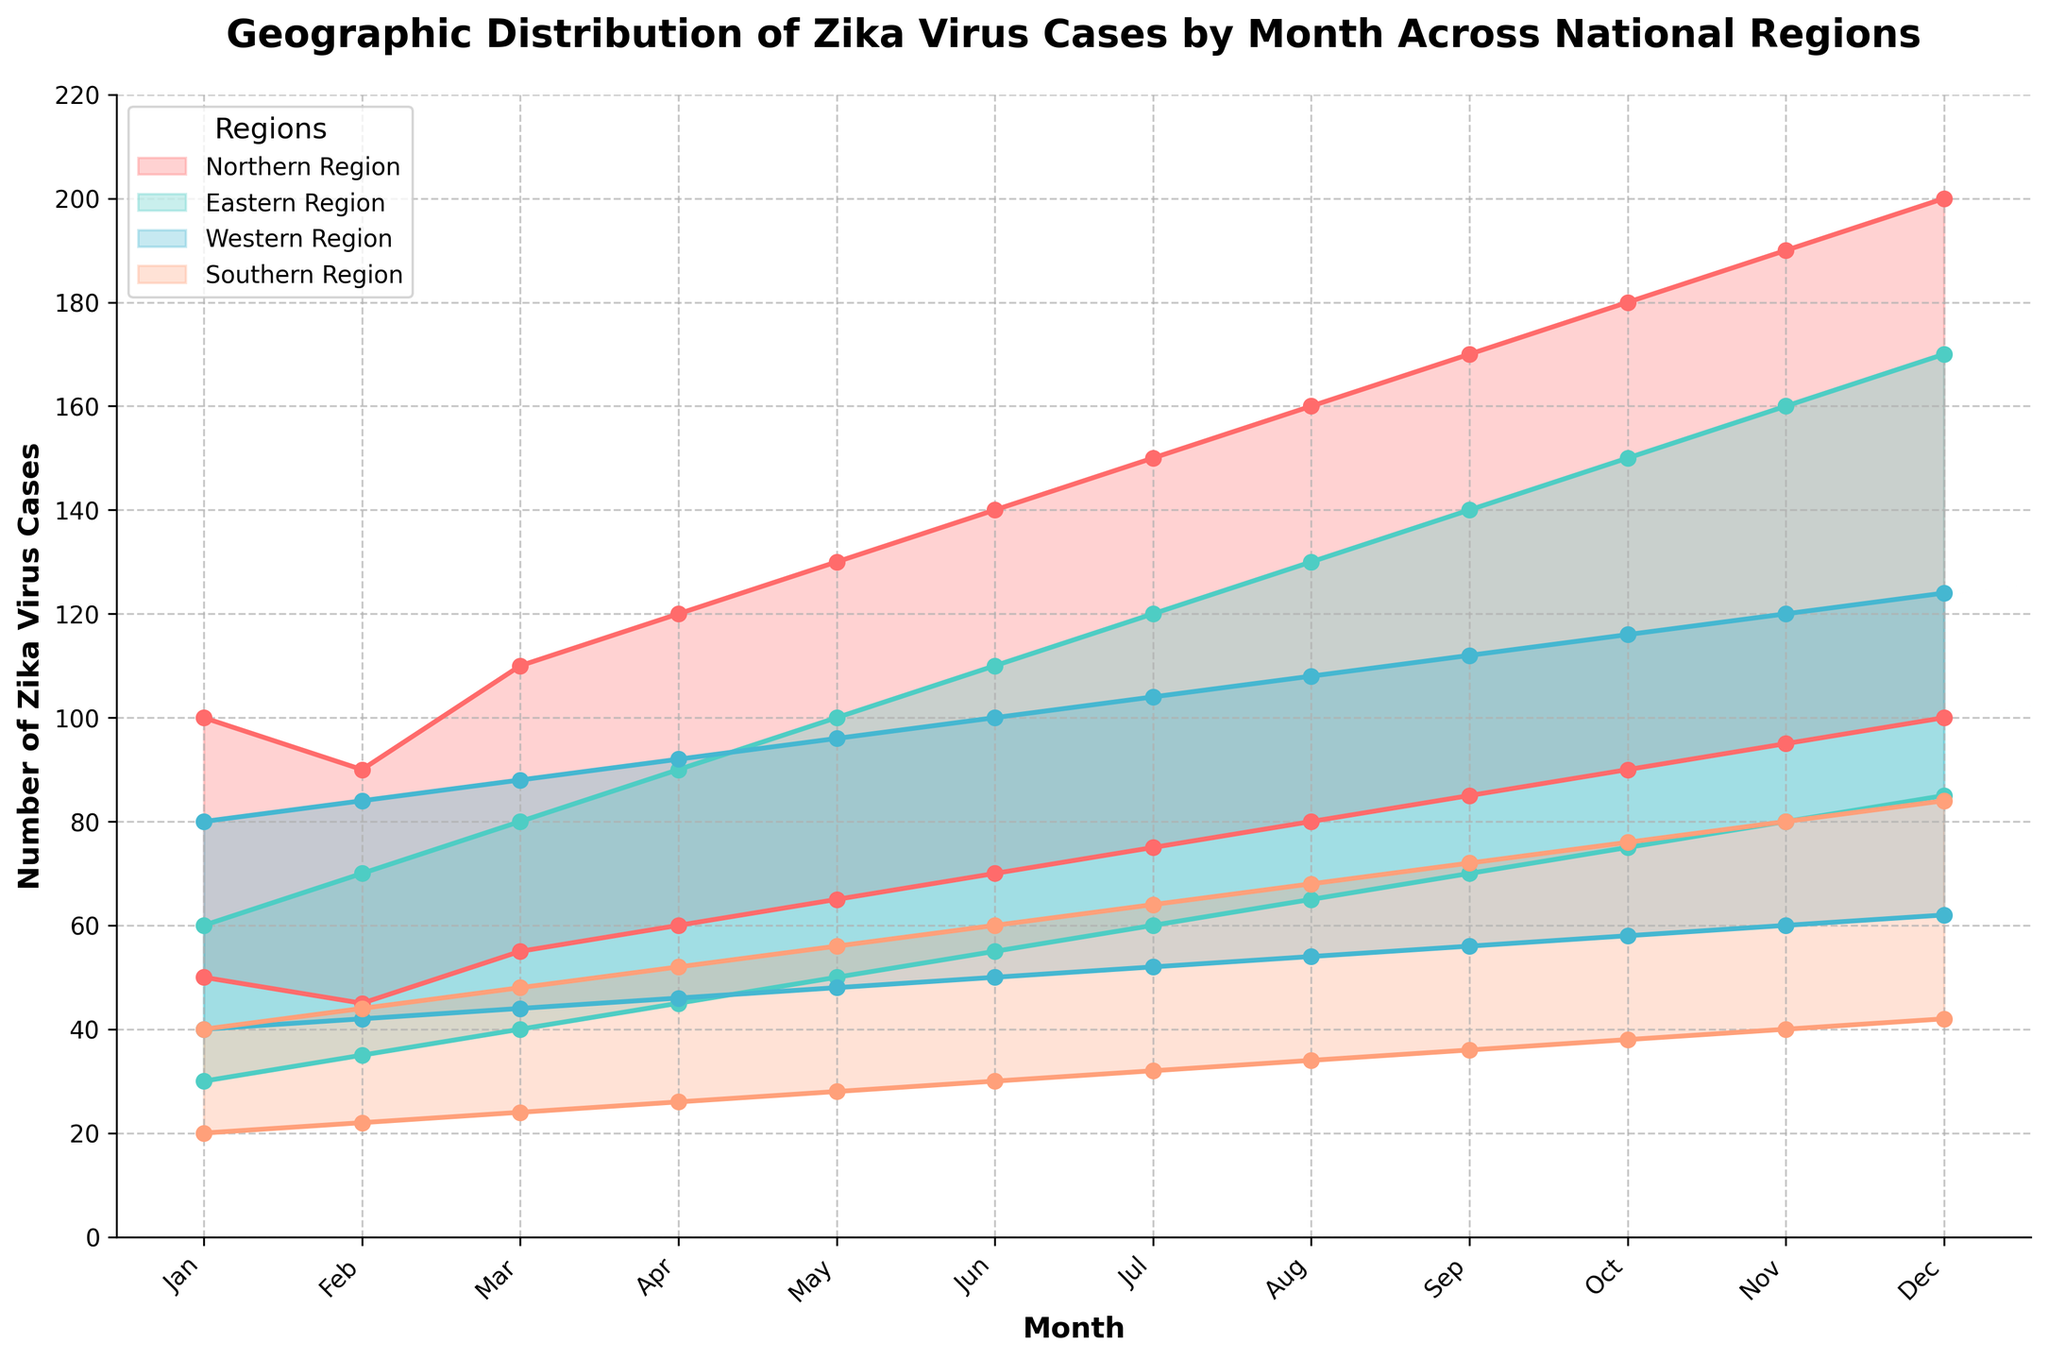What's the title of the chart? The title is at the top of the chart, stating what the chart represents.
Answer: Geographic Distribution of Zika Virus Cases by Month Across National Regions Which month had the highest number of Zika virus cases in the Northern Region? The highest number of cases corresponds to the peak of the shaded area for the Northern Region, which is in December.
Answer: December In which month does the Eastern Region have the minimum reported range of Zika virus cases? The minimum range starts in January, with the narrowest range between the lowest and highest cases.
Answer: January Compare the maximum cases of the Southern Region in July and November. Which month had a higher number? Look at the peak of the shaded areas between July and November, observing the y-axis values.
Answer: November What is the overall trend in Zika virus cases for the Western Region throughout the year? Follow the plot lines for the Western Region from January to December. The trend shows a gradual increase.
Answer: Gradual increase Which region reports the highest range of cases in August? Compare the shading areas' widths for all regions in August; the Northern Region has the widest range.
Answer: Northern Region What is the difference between the maximum cases reported in the Northern and Southern Regions in December? Dec: Northern (200) - Southern (84).
Answer: 116 What is the average minimum number of cases reported in the Western Region for the first quarter of the year (January to March)? Sum (40 + 42 + 44) and divide by 3. (40+42+44) / 3 = 42.
Answer: 42 Which region shows the least variability in the number of cases across the year? Determine by comparing the width consistency for the shaded ranges of all regions; the Southern Region has the narrowest and most consistent range.
Answer: Southern Region How does the trend in the Eastern Region compare to that of the Northern Region throughout the year? The Northern Region's cases exponentially increase while the Eastern experiences a steadier, more linear increase.
Answer: Exponential vs. linear increase 